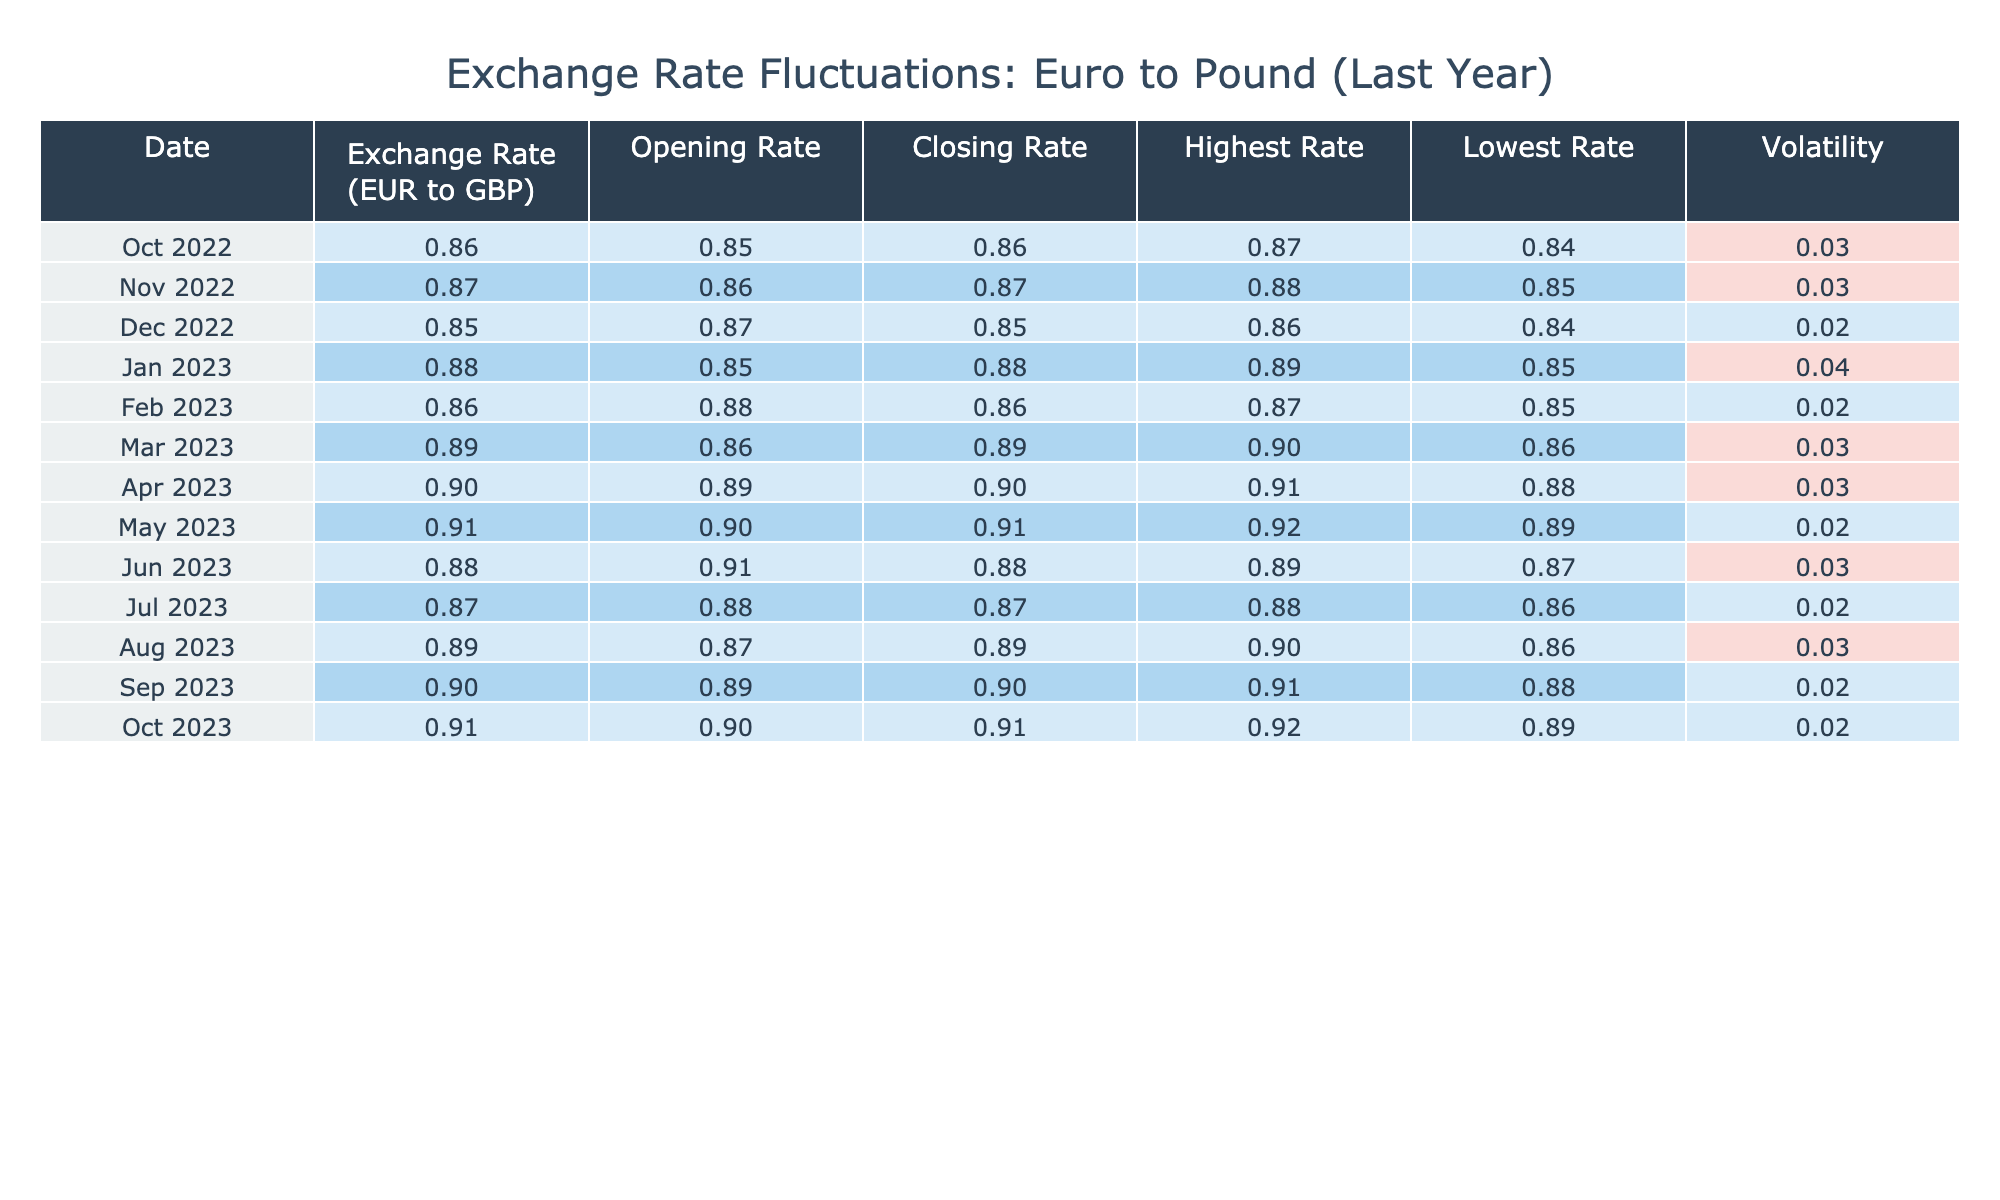What was the highest exchange rate recorded in the last year? The highest exchange rate in the table is 0.92, which was recorded in May 2023 and October 2023.
Answer: 0.92 What was the exchange rate on June 1st, 2023? The table shows that the exchange rate on June 1st, 2023, was 0.88.
Answer: 0.88 What is the average exchange rate over the last year? To find the average exchange rate, sum up all exchange rates: 0.86 + 0.87 + 0.85 + 0.88 + 0.86 + 0.89 + 0.90 + 0.91 + 0.88 + 0.87 + 0.89 + 0.90 + 0.91 = 10.55. There are 13 months, so divide 10.55 by 13, which gives approximately 0.81.
Answer: 0.81 Was the volatility ever above 0.03 during the last year? Yes, the table indicates that the volatility was above 0.03 in January 2023, when it reached 0.04.
Answer: Yes What is the difference between the highest and lowest exchange rates recorded in this table? The highest exchange rate is 0.92 and the lowest is 0.84. The difference is calculated as 0.92 - 0.84 = 0.08.
Answer: 0.08 What was the closing rate for October 1st, 2023? According to the table, the closing rate for October 1st, 2023, was 0.91.
Answer: 0.91 Which month had the lowest volatility, and what was that value? By reviewing the table, July 2023 shows a volatility of 0.02, making it the month with the lowest volatility.
Answer: July 2023, 0.02 In which month did the exchange rate first reach or exceed 0.90? The exchange rate first reached or exceeded 0.90 in April 2023, where the rate was 0.90.
Answer: April 2023 